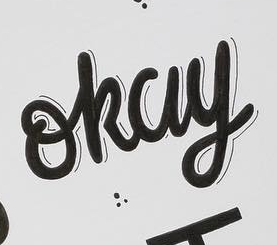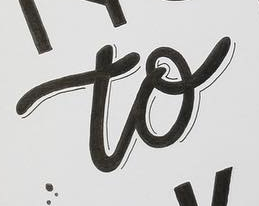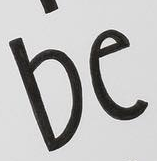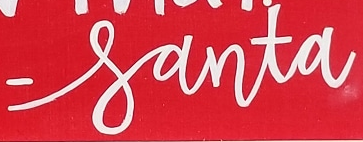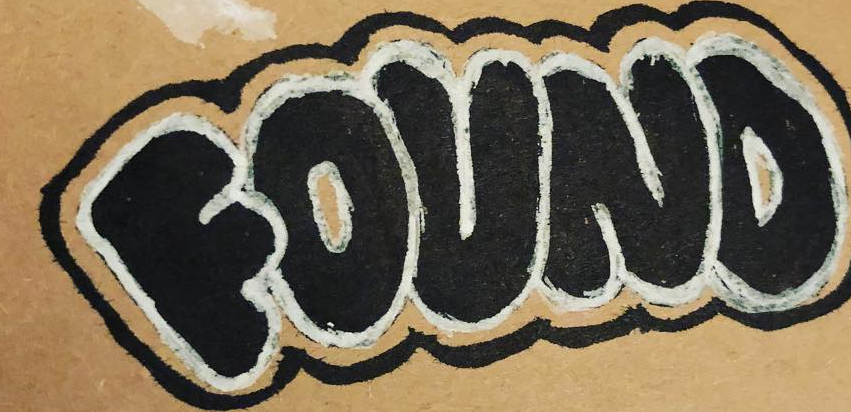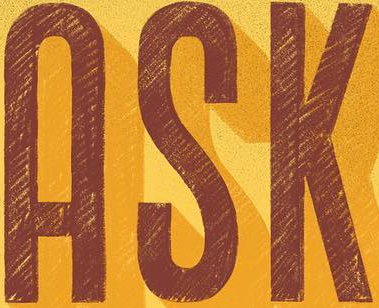What text is displayed in these images sequentially, separated by a semicolon? okay; to; be; -santa; FOUND; ASK 